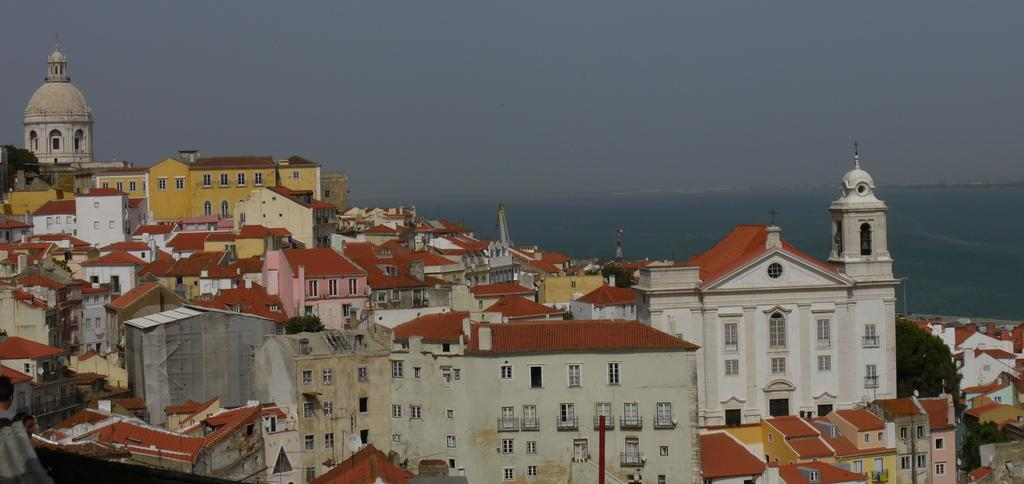What is the primary subject of the image? The primary subject of the image is many buildings. Can you describe the background of the image? The background of the image features water. What type of hat is the minister wearing in the image? There is no minister or hat present in the image; it features many buildings and water in the background. 